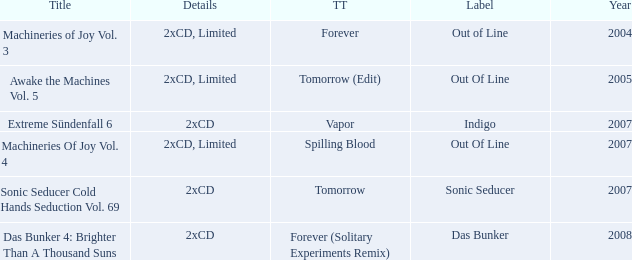Which details has the out of line label and the year of 2005? 2xCD, Limited. 